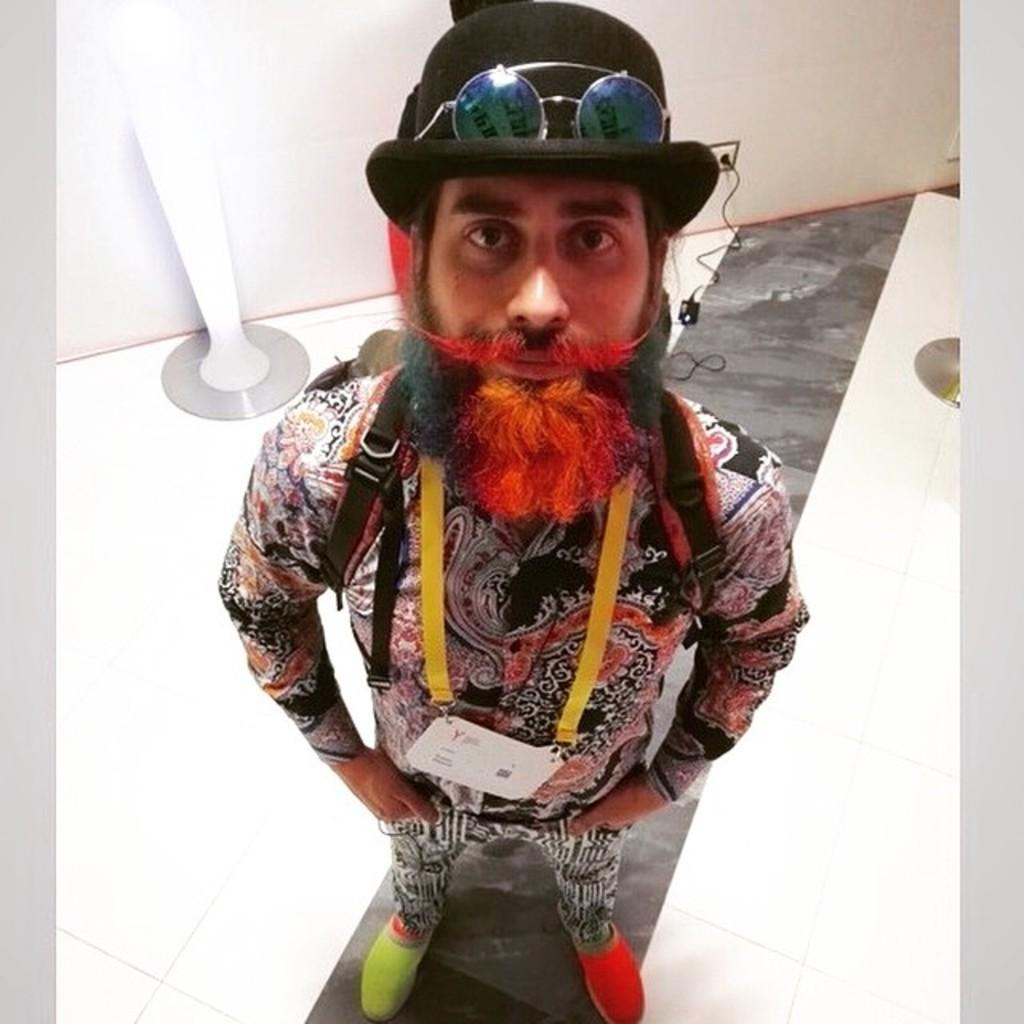What is the main subject of the image? There is a man standing in the image. What is the man wearing in the image? The man is wearing a costume. What can be seen in the background of the image? There is a cable connected to a switch board in the background of the image. Can you hear the mother laughing in the image? There is no mother or laughter present in the image; it only features a man in a costume and a cable connected to a switch board. 